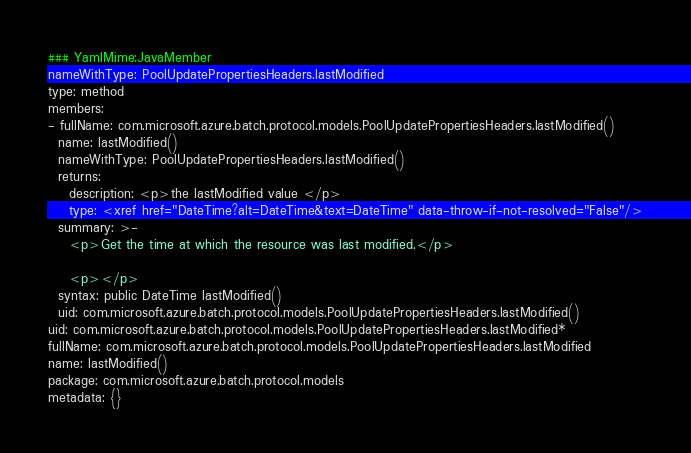Convert code to text. <code><loc_0><loc_0><loc_500><loc_500><_YAML_>### YamlMime:JavaMember
nameWithType: PoolUpdatePropertiesHeaders.lastModified
type: method
members:
- fullName: com.microsoft.azure.batch.protocol.models.PoolUpdatePropertiesHeaders.lastModified()
  name: lastModified()
  nameWithType: PoolUpdatePropertiesHeaders.lastModified()
  returns:
    description: <p>the lastModified value </p>
    type: <xref href="DateTime?alt=DateTime&text=DateTime" data-throw-if-not-resolved="False"/>
  summary: >-
    <p>Get the time at which the resource was last modified.</p>

    <p></p>
  syntax: public DateTime lastModified()
  uid: com.microsoft.azure.batch.protocol.models.PoolUpdatePropertiesHeaders.lastModified()
uid: com.microsoft.azure.batch.protocol.models.PoolUpdatePropertiesHeaders.lastModified*
fullName: com.microsoft.azure.batch.protocol.models.PoolUpdatePropertiesHeaders.lastModified
name: lastModified()
package: com.microsoft.azure.batch.protocol.models
metadata: {}
</code> 